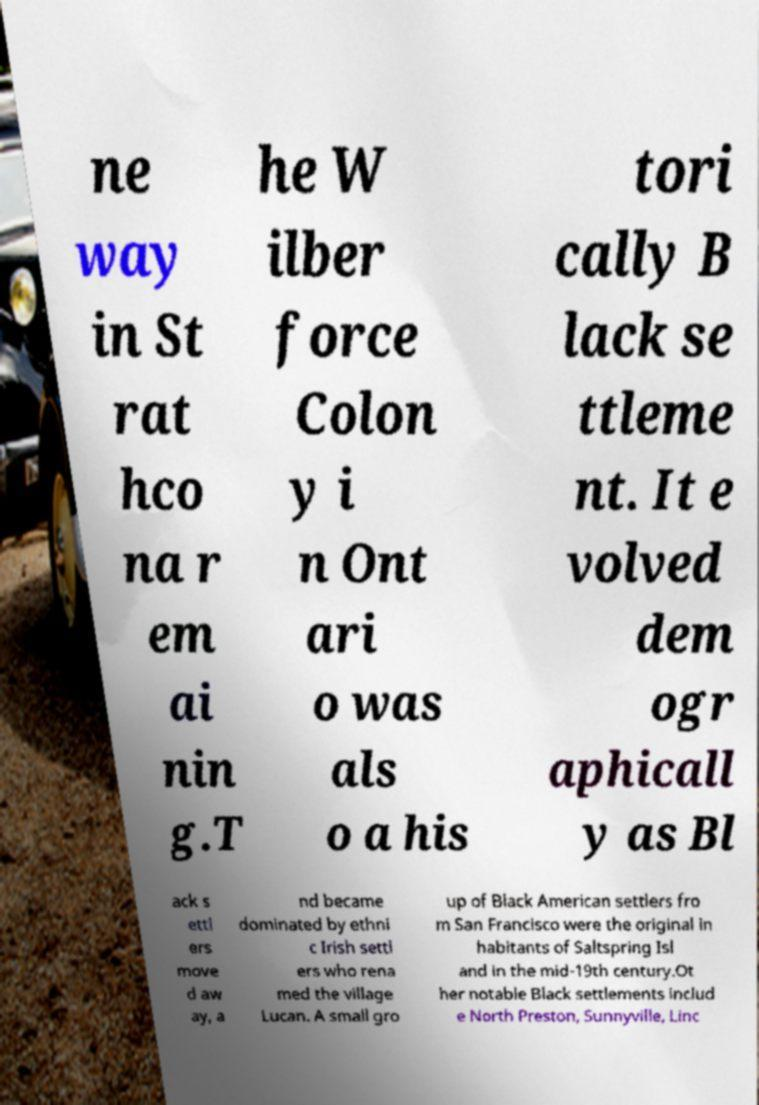Can you read and provide the text displayed in the image?This photo seems to have some interesting text. Can you extract and type it out for me? ne way in St rat hco na r em ai nin g.T he W ilber force Colon y i n Ont ari o was als o a his tori cally B lack se ttleme nt. It e volved dem ogr aphicall y as Bl ack s ettl ers move d aw ay, a nd became dominated by ethni c Irish settl ers who rena med the village Lucan. A small gro up of Black American settlers fro m San Francisco were the original in habitants of Saltspring Isl and in the mid-19th century.Ot her notable Black settlements includ e North Preston, Sunnyville, Linc 